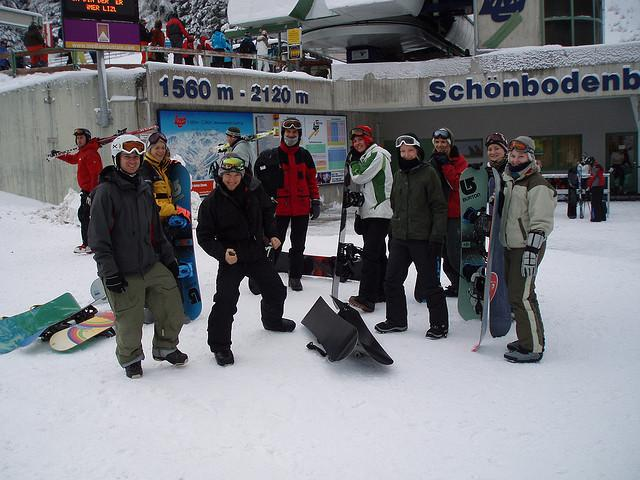This photo was taken in front of what kind of attraction? Please explain your reasoning. ski lodge. There is a lot of snow and ski equipment with them 